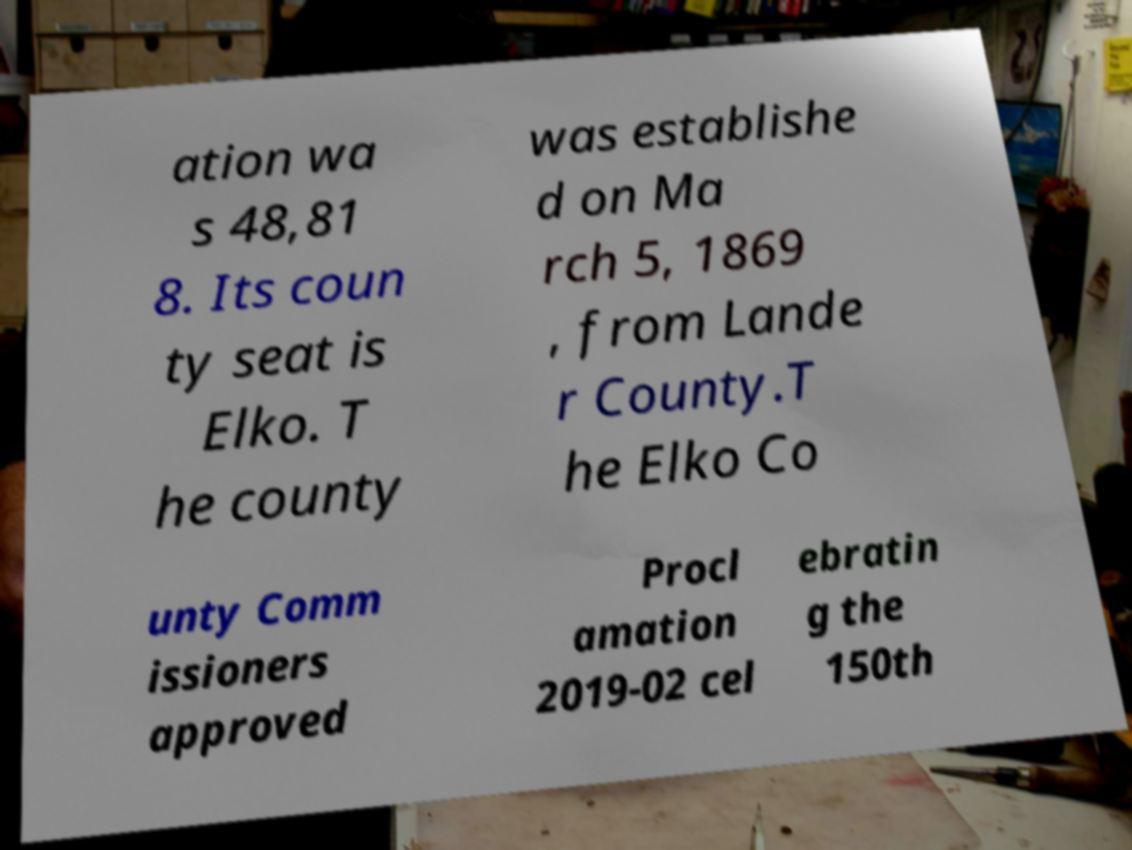Please identify and transcribe the text found in this image. ation wa s 48,81 8. Its coun ty seat is Elko. T he county was establishe d on Ma rch 5, 1869 , from Lande r County.T he Elko Co unty Comm issioners approved Procl amation 2019-02 cel ebratin g the 150th 